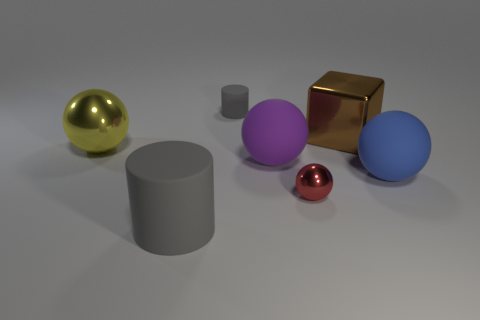Add 2 big gray matte blocks. How many objects exist? 9 Subtract all cylinders. How many objects are left? 5 Add 1 small metallic cylinders. How many small metallic cylinders exist? 1 Subtract 0 green cubes. How many objects are left? 7 Subtract all large blue rubber balls. Subtract all big gray objects. How many objects are left? 5 Add 4 large matte cylinders. How many large matte cylinders are left? 5 